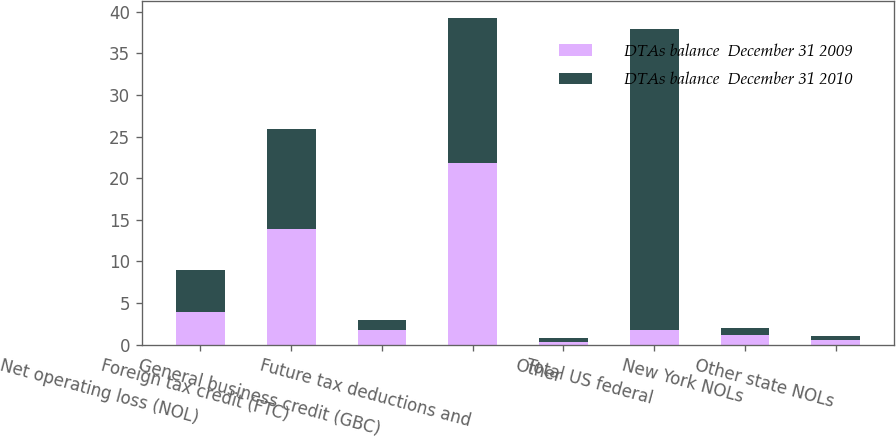Convert chart. <chart><loc_0><loc_0><loc_500><loc_500><stacked_bar_chart><ecel><fcel>Net operating loss (NOL)<fcel>Foreign tax credit (FTC)<fcel>General business credit (GBC)<fcel>Future tax deductions and<fcel>Other<fcel>Total US federal<fcel>New York NOLs<fcel>Other state NOLs<nl><fcel>DTAs balance  December 31 2009<fcel>3.9<fcel>13.9<fcel>1.7<fcel>21.8<fcel>0.3<fcel>1.7<fcel>1.1<fcel>0.6<nl><fcel>DTAs balance  December 31 2010<fcel>5.1<fcel>12<fcel>1.2<fcel>17.5<fcel>0.5<fcel>36.3<fcel>0.9<fcel>0.4<nl></chart> 